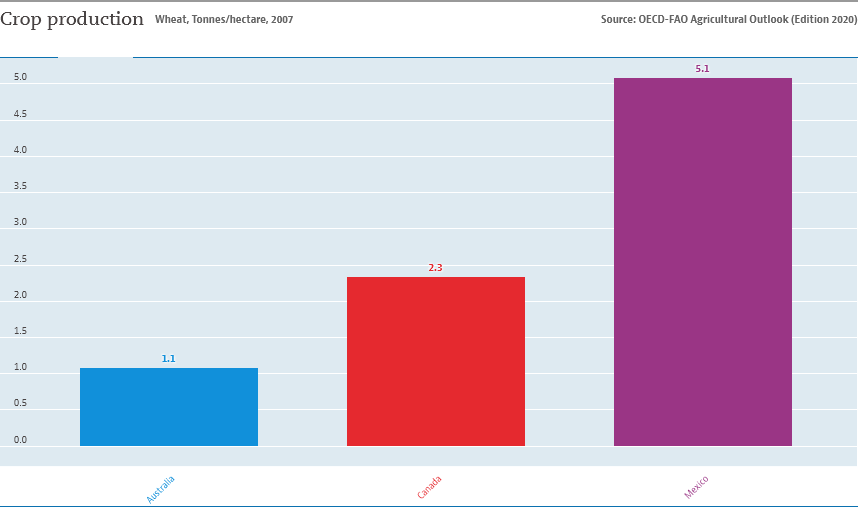Point out several critical features in this image. The wheat production in Mexico in 2007 was greater than the combined production of Australia and Canada in terms of both tonnes and hectares. In Canada in 2007, the amount of wheat production was 2.3 tonnes per hectare. 